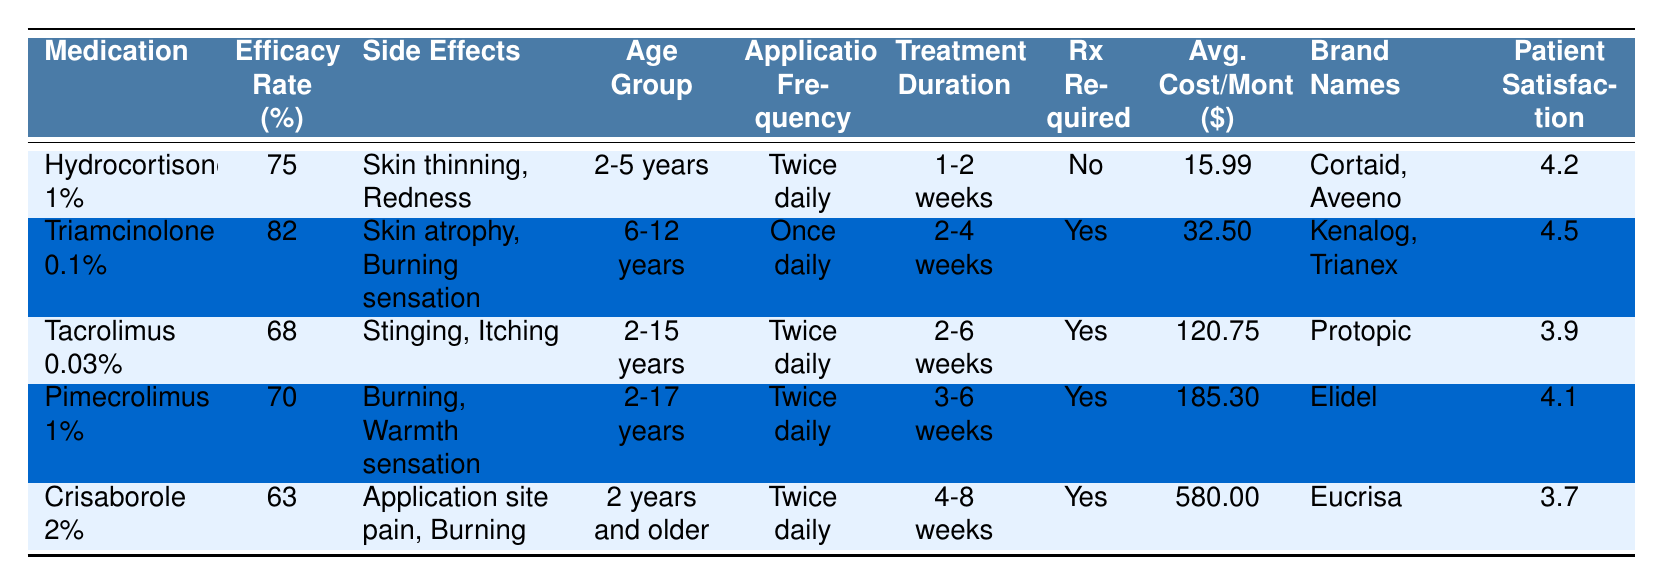What is the efficacy rate of Triamcinolone 0.1%? The efficacy rate for Triamcinolone 0.1% is listed in the table. It shows a value of 82%.
Answer: 82% Which medication has the highest average monthly cost? By comparing the "Avg. Cost/Month" column, Crisaborole 2% has the highest value at $580.00.
Answer: Crisaborole 2% Are any of the medications available without a prescription? The table indicates that Hydrocortisone 1% does not require a prescription as indicated by "No" in the "Rx Required" column.
Answer: Yes Which medication has the highest patient satisfaction rating? Reviewing the "Patient Satisfaction" column, Triamcinolone 0.1% has the highest rating at 4.5.
Answer: Triamcinolone 0.1% What is the average efficacy rate of the medications listed? The efficacy rates are 75, 82, 68, 70, and 63. To find the average, add them up (75 + 82 + 68 + 70 + 63 = 358) and divide by 5, resulting in an average of 71.6.
Answer: 71.6 Which medication is approved for the widest age range? Pimecrolimus 1% can be used for ages 2-17 years, while the other medications have narrower age groups, making it the one with the widest range.
Answer: Pimecrolimus 1% What are the side effects of Crisaborole 2%? The side effects listed for Crisaborole 2% are "Application site pain, Burning," which are shown in the side effects column.
Answer: Application site pain, Burning Is there a medication that requires a prescription and has a cost lower than $100? Triamcinolone 0.1% and Tacrolimus 0.03% require prescriptions and have costs of $32.50 and $120.75 respectively, but only Triamcinolone has a cost under $100.
Answer: Yes What is the main side effect of Tacrolimus 0.03%? The side effects for Tacrolimus 0.03% are "Stinging, Itching," as recorded in the table.
Answer: Stinging, Itching Which two medications have a treatment duration of 3-6 weeks? The treatment duration column shows that Pimecrolimus 1% and Crisaborole 2% have treatment durations of 3-6 weeks specified.
Answer: Pimecrolimus 1%, Crisaborole 2% 